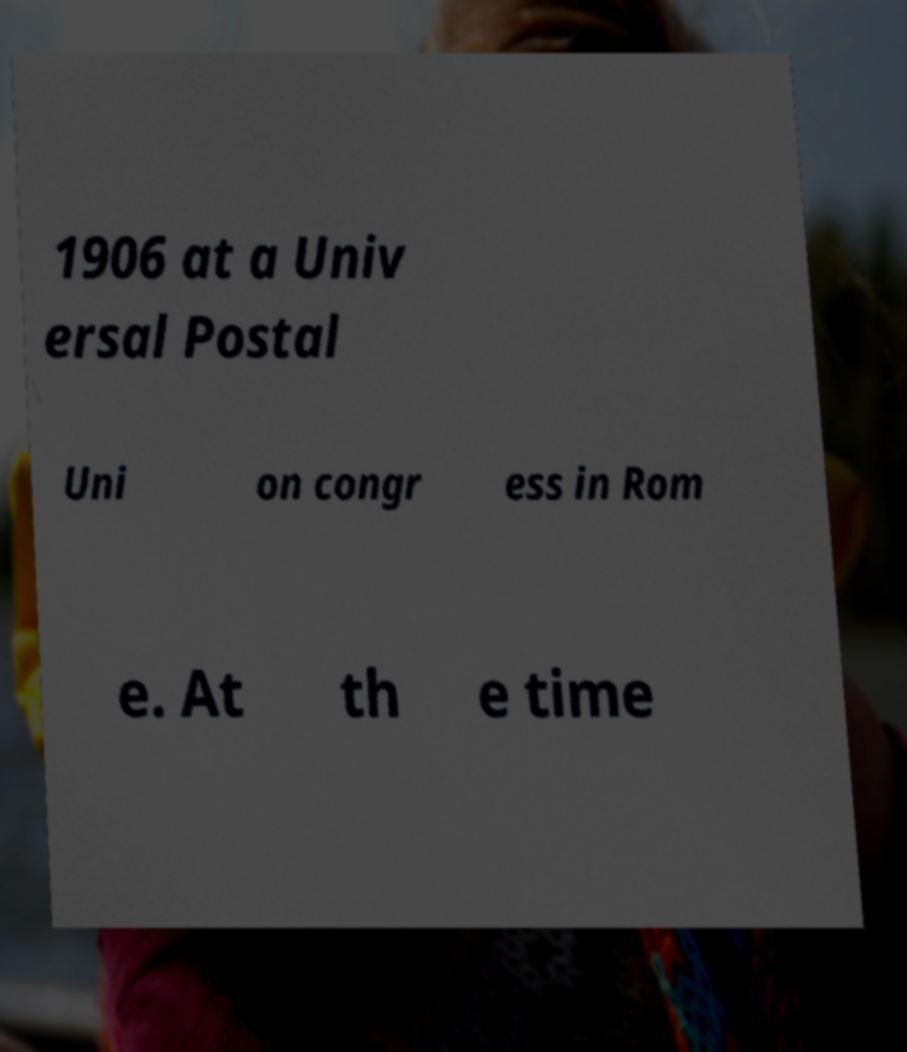Could you extract and type out the text from this image? 1906 at a Univ ersal Postal Uni on congr ess in Rom e. At th e time 